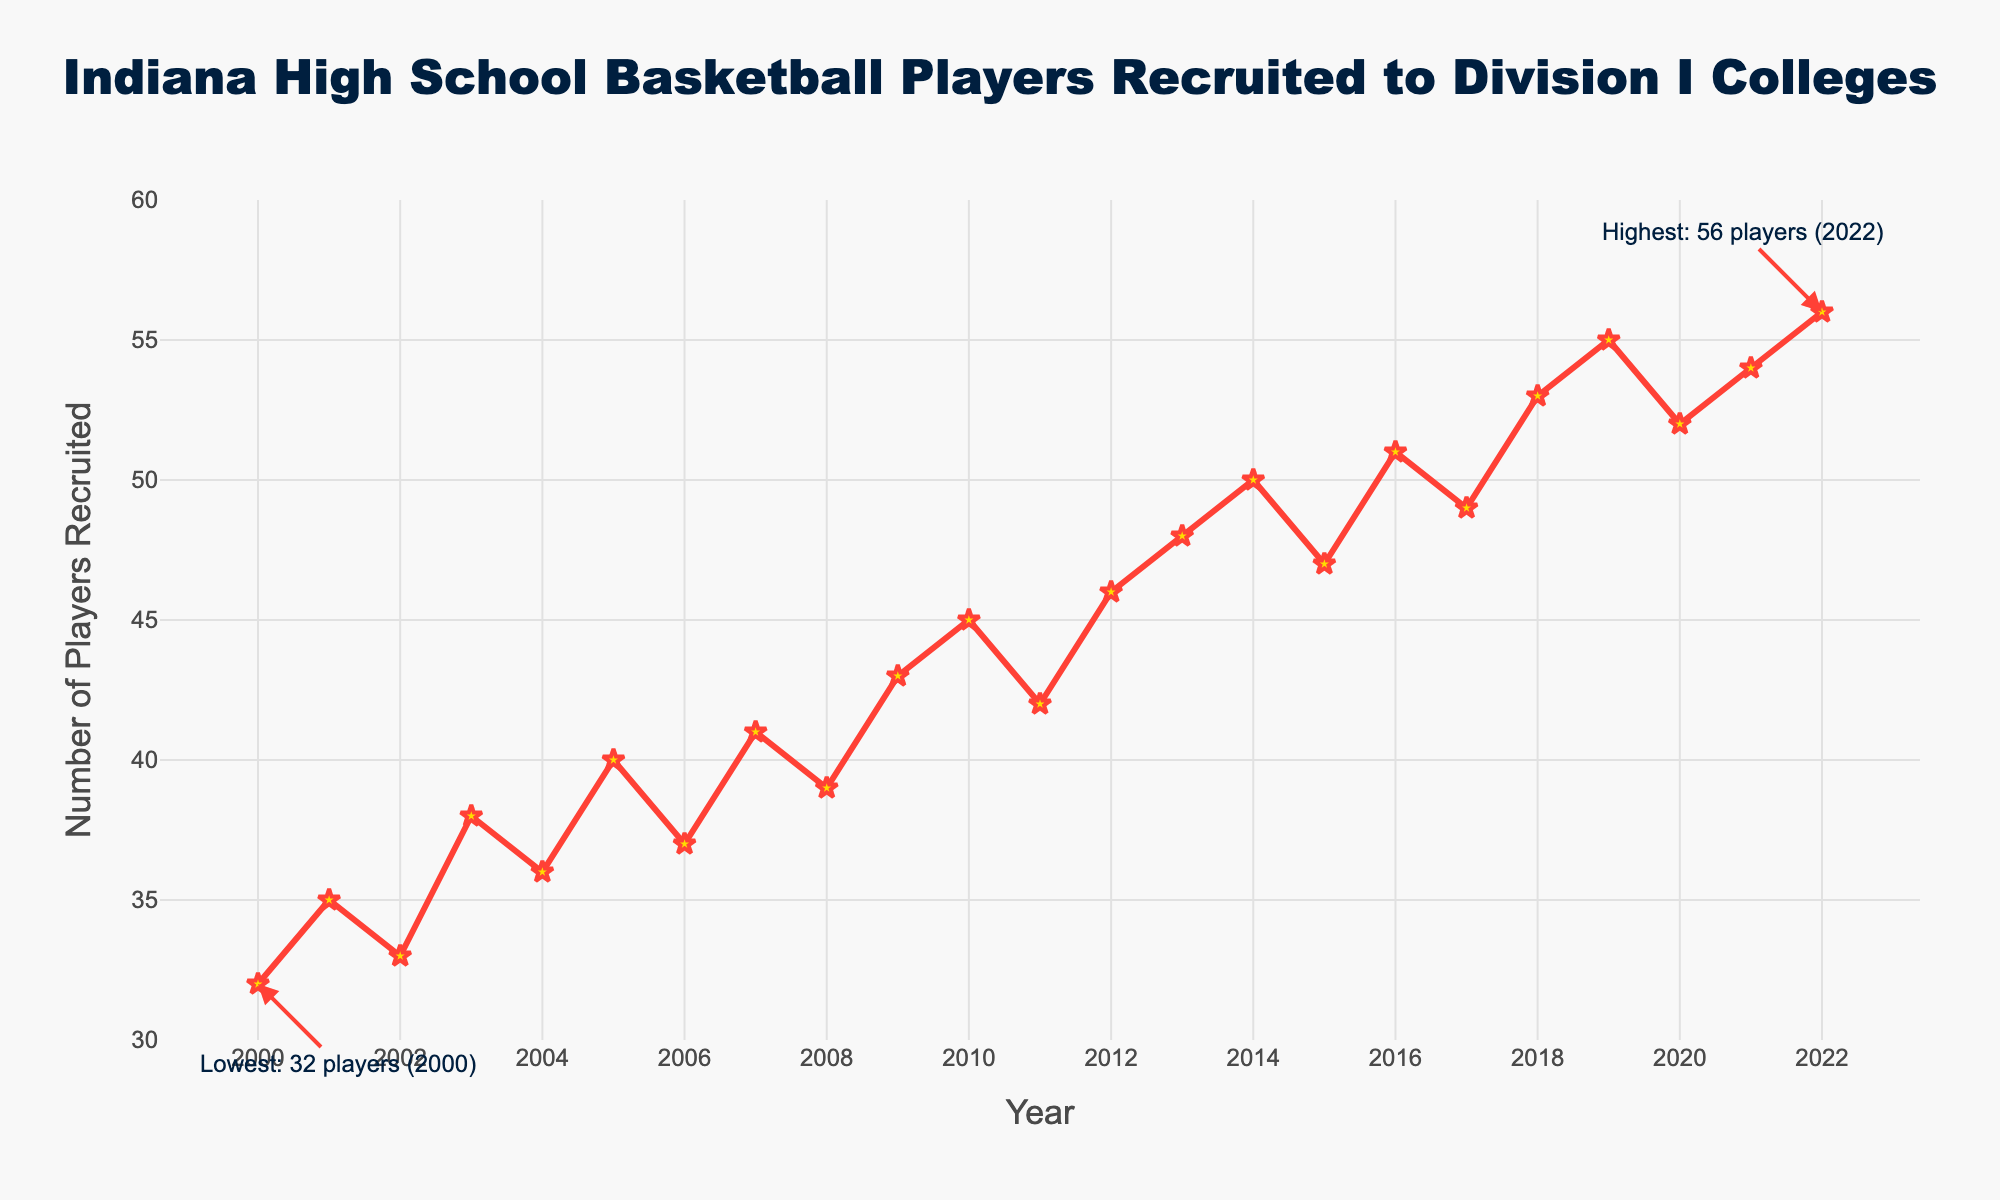What's the overall trend in the number of Indiana high school basketball players recruited to Division I colleges from 2000 to 2022? Over the years, the number of players recruited shows an increasing trend. Starting from 32 in 2000 and rising up to 56 in 2022, there is a clear upward movement in the recruitment numbers.
Answer: Increasing What was the highest number of players recruited in a single year, and in what year did it occur? The figure annotates the highest number of recruits, showing 56 players were recruited in 2022.
Answer: 56, 2022 What was the lowest number of players recruited in a single year, and in what year did it occur? The figure annotates the lowest number of recruits, indicating 32 players were recruited in 2000.
Answer: 32, 2000 By how much did the number of players recruited increase from 2000 to 2022? From 2000 to 2022, the number of players recruited increased from 32 to 56. The difference is calculated as 56 - 32.
Answer: 24 In which year(s) did the number of players recruited first surpass 50? Checking the plot, the first year where recruits surpassed 50 players is 2016.
Answer: 2016 What's the average number of players recruited per year from 2000 to 2022? The total sum of players recruited from 2000 to 2022 is 1049. Since there are 23 years, the average is 1049 / 23.
Answer: 45.61 Compare the number of players recruited in 2010 to 2018. Which year had more recruits and by how much? In 2010, there were 45 players recruited, and in 2018, there were 53 players recruited. The difference is 53 - 45.
Answer: 2018 by 8 players What is the general frequency of the increase in players recruited between consecutive years? From visual inspection, the number of players generally increases almost every other year, maintaining an upward trajectory with occasional decreases.
Answer: Frequent increases How many times did the number of recruited players decrease compared to the previous year between 2000 and 2022? Checking the plot, decreases occurred from 2011 to 2012, 2014 to 2015, 2015 to 2016, 2017 to 2018, and 2019 to 2020.
Answer: 5 times From the plotted trend, in which decades (2000-2010 or 2011-2022) is the growth in player recruitment more prominent? Comparing both periods, the 2011-2022 decade has a more significant rise in player recruitment, as seen in the steeper slope of the line in this period.
Answer: 2011-2022 